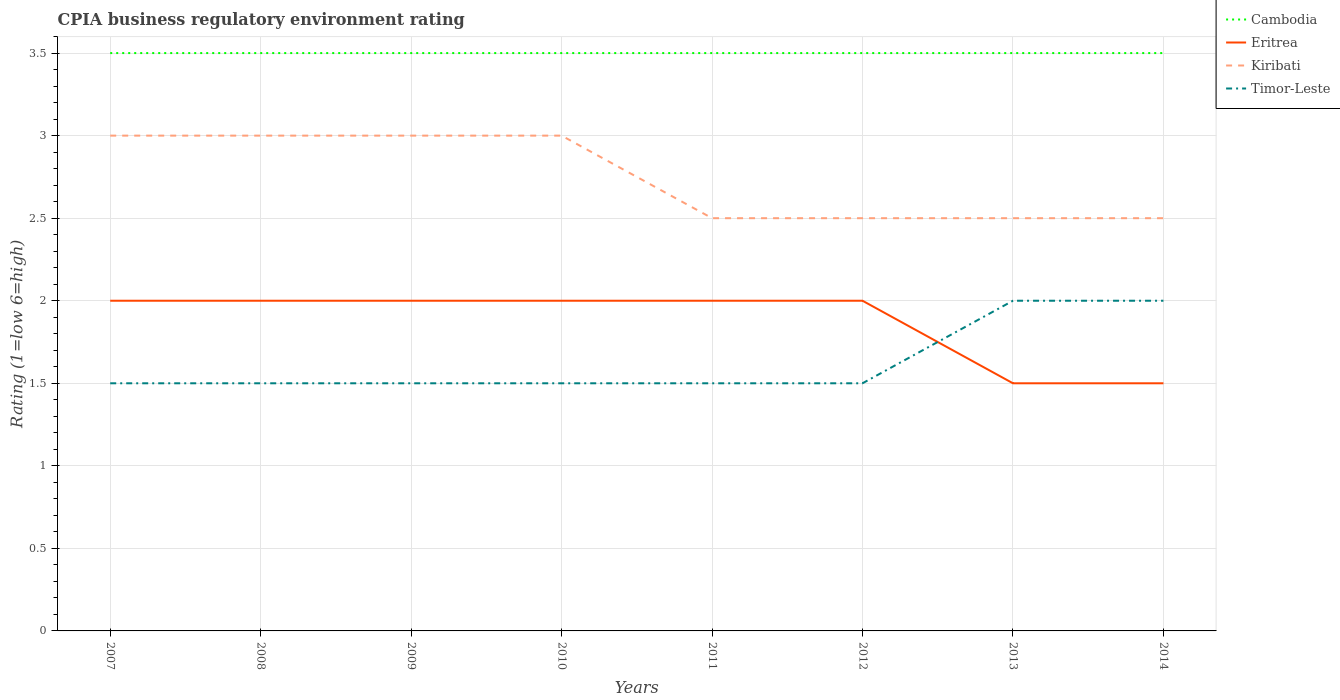In which year was the CPIA rating in Eritrea maximum?
Your answer should be compact. 2013. What is the difference between the highest and the lowest CPIA rating in Eritrea?
Give a very brief answer. 6. What is the difference between two consecutive major ticks on the Y-axis?
Your answer should be very brief. 0.5. Are the values on the major ticks of Y-axis written in scientific E-notation?
Offer a very short reply. No. Does the graph contain any zero values?
Provide a short and direct response. No. Does the graph contain grids?
Provide a succinct answer. Yes. How are the legend labels stacked?
Your answer should be very brief. Vertical. What is the title of the graph?
Ensure brevity in your answer.  CPIA business regulatory environment rating. Does "Greece" appear as one of the legend labels in the graph?
Provide a short and direct response. No. What is the label or title of the Y-axis?
Ensure brevity in your answer.  Rating (1=low 6=high). What is the Rating (1=low 6=high) in Eritrea in 2007?
Your answer should be very brief. 2. What is the Rating (1=low 6=high) of Kiribati in 2007?
Ensure brevity in your answer.  3. What is the Rating (1=low 6=high) in Cambodia in 2008?
Your response must be concise. 3.5. What is the Rating (1=low 6=high) in Eritrea in 2008?
Your answer should be very brief. 2. What is the Rating (1=low 6=high) in Kiribati in 2008?
Provide a short and direct response. 3. What is the Rating (1=low 6=high) in Timor-Leste in 2008?
Offer a very short reply. 1.5. What is the Rating (1=low 6=high) in Cambodia in 2009?
Give a very brief answer. 3.5. What is the Rating (1=low 6=high) of Eritrea in 2009?
Your answer should be compact. 2. What is the Rating (1=low 6=high) in Timor-Leste in 2009?
Your answer should be very brief. 1.5. What is the Rating (1=low 6=high) of Cambodia in 2010?
Keep it short and to the point. 3.5. What is the Rating (1=low 6=high) in Eritrea in 2010?
Provide a succinct answer. 2. What is the Rating (1=low 6=high) of Timor-Leste in 2010?
Your answer should be compact. 1.5. What is the Rating (1=low 6=high) of Eritrea in 2011?
Ensure brevity in your answer.  2. What is the Rating (1=low 6=high) of Timor-Leste in 2011?
Keep it short and to the point. 1.5. What is the Rating (1=low 6=high) in Eritrea in 2012?
Provide a succinct answer. 2. What is the Rating (1=low 6=high) of Cambodia in 2013?
Make the answer very short. 3.5. What is the Rating (1=low 6=high) of Timor-Leste in 2013?
Your response must be concise. 2. What is the Rating (1=low 6=high) of Cambodia in 2014?
Your response must be concise. 3.5. Across all years, what is the maximum Rating (1=low 6=high) in Kiribati?
Make the answer very short. 3. Across all years, what is the maximum Rating (1=low 6=high) in Timor-Leste?
Provide a short and direct response. 2. Across all years, what is the minimum Rating (1=low 6=high) of Eritrea?
Make the answer very short. 1.5. Across all years, what is the minimum Rating (1=low 6=high) of Timor-Leste?
Offer a very short reply. 1.5. What is the total Rating (1=low 6=high) of Kiribati in the graph?
Make the answer very short. 22. What is the total Rating (1=low 6=high) in Timor-Leste in the graph?
Your answer should be compact. 13. What is the difference between the Rating (1=low 6=high) in Kiribati in 2007 and that in 2009?
Offer a terse response. 0. What is the difference between the Rating (1=low 6=high) of Timor-Leste in 2007 and that in 2009?
Ensure brevity in your answer.  0. What is the difference between the Rating (1=low 6=high) in Cambodia in 2007 and that in 2010?
Provide a succinct answer. 0. What is the difference between the Rating (1=low 6=high) in Eritrea in 2007 and that in 2010?
Your response must be concise. 0. What is the difference between the Rating (1=low 6=high) in Kiribati in 2007 and that in 2010?
Offer a terse response. 0. What is the difference between the Rating (1=low 6=high) of Eritrea in 2007 and that in 2011?
Provide a short and direct response. 0. What is the difference between the Rating (1=low 6=high) of Kiribati in 2007 and that in 2011?
Offer a very short reply. 0.5. What is the difference between the Rating (1=low 6=high) of Eritrea in 2007 and that in 2012?
Ensure brevity in your answer.  0. What is the difference between the Rating (1=low 6=high) of Cambodia in 2007 and that in 2013?
Give a very brief answer. 0. What is the difference between the Rating (1=low 6=high) in Kiribati in 2007 and that in 2013?
Your answer should be compact. 0.5. What is the difference between the Rating (1=low 6=high) of Cambodia in 2007 and that in 2014?
Keep it short and to the point. 0. What is the difference between the Rating (1=low 6=high) of Eritrea in 2007 and that in 2014?
Provide a succinct answer. 0.5. What is the difference between the Rating (1=low 6=high) of Kiribati in 2007 and that in 2014?
Your answer should be compact. 0.5. What is the difference between the Rating (1=low 6=high) in Timor-Leste in 2007 and that in 2014?
Offer a terse response. -0.5. What is the difference between the Rating (1=low 6=high) in Cambodia in 2008 and that in 2010?
Ensure brevity in your answer.  0. What is the difference between the Rating (1=low 6=high) of Kiribati in 2008 and that in 2010?
Make the answer very short. 0. What is the difference between the Rating (1=low 6=high) in Cambodia in 2008 and that in 2011?
Provide a succinct answer. 0. What is the difference between the Rating (1=low 6=high) of Eritrea in 2008 and that in 2011?
Your answer should be very brief. 0. What is the difference between the Rating (1=low 6=high) in Kiribati in 2008 and that in 2012?
Provide a succinct answer. 0.5. What is the difference between the Rating (1=low 6=high) of Kiribati in 2008 and that in 2013?
Your response must be concise. 0.5. What is the difference between the Rating (1=low 6=high) of Timor-Leste in 2008 and that in 2013?
Your answer should be very brief. -0.5. What is the difference between the Rating (1=low 6=high) in Cambodia in 2008 and that in 2014?
Provide a short and direct response. 0. What is the difference between the Rating (1=low 6=high) in Eritrea in 2008 and that in 2014?
Your answer should be very brief. 0.5. What is the difference between the Rating (1=low 6=high) of Cambodia in 2009 and that in 2010?
Provide a succinct answer. 0. What is the difference between the Rating (1=low 6=high) of Eritrea in 2009 and that in 2010?
Your answer should be compact. 0. What is the difference between the Rating (1=low 6=high) in Kiribati in 2009 and that in 2010?
Give a very brief answer. 0. What is the difference between the Rating (1=low 6=high) of Timor-Leste in 2009 and that in 2010?
Make the answer very short. 0. What is the difference between the Rating (1=low 6=high) of Cambodia in 2009 and that in 2011?
Give a very brief answer. 0. What is the difference between the Rating (1=low 6=high) of Kiribati in 2009 and that in 2011?
Provide a short and direct response. 0.5. What is the difference between the Rating (1=low 6=high) of Timor-Leste in 2009 and that in 2011?
Your answer should be very brief. 0. What is the difference between the Rating (1=low 6=high) of Cambodia in 2009 and that in 2012?
Ensure brevity in your answer.  0. What is the difference between the Rating (1=low 6=high) of Kiribati in 2009 and that in 2012?
Give a very brief answer. 0.5. What is the difference between the Rating (1=low 6=high) in Timor-Leste in 2009 and that in 2012?
Provide a short and direct response. 0. What is the difference between the Rating (1=low 6=high) of Cambodia in 2009 and that in 2013?
Offer a terse response. 0. What is the difference between the Rating (1=low 6=high) of Cambodia in 2009 and that in 2014?
Your answer should be compact. 0. What is the difference between the Rating (1=low 6=high) in Kiribati in 2009 and that in 2014?
Give a very brief answer. 0.5. What is the difference between the Rating (1=low 6=high) of Timor-Leste in 2009 and that in 2014?
Ensure brevity in your answer.  -0.5. What is the difference between the Rating (1=low 6=high) in Cambodia in 2010 and that in 2011?
Offer a very short reply. 0. What is the difference between the Rating (1=low 6=high) in Eritrea in 2010 and that in 2011?
Give a very brief answer. 0. What is the difference between the Rating (1=low 6=high) of Kiribati in 2010 and that in 2011?
Your answer should be compact. 0.5. What is the difference between the Rating (1=low 6=high) of Cambodia in 2010 and that in 2012?
Offer a very short reply. 0. What is the difference between the Rating (1=low 6=high) of Eritrea in 2010 and that in 2012?
Your answer should be very brief. 0. What is the difference between the Rating (1=low 6=high) in Kiribati in 2010 and that in 2012?
Keep it short and to the point. 0.5. What is the difference between the Rating (1=low 6=high) in Timor-Leste in 2010 and that in 2012?
Your answer should be very brief. 0. What is the difference between the Rating (1=low 6=high) in Kiribati in 2010 and that in 2013?
Your answer should be compact. 0.5. What is the difference between the Rating (1=low 6=high) of Timor-Leste in 2010 and that in 2013?
Offer a very short reply. -0.5. What is the difference between the Rating (1=low 6=high) in Kiribati in 2010 and that in 2014?
Give a very brief answer. 0.5. What is the difference between the Rating (1=low 6=high) of Timor-Leste in 2010 and that in 2014?
Your response must be concise. -0.5. What is the difference between the Rating (1=low 6=high) in Eritrea in 2011 and that in 2012?
Offer a terse response. 0. What is the difference between the Rating (1=low 6=high) of Kiribati in 2011 and that in 2012?
Give a very brief answer. 0. What is the difference between the Rating (1=low 6=high) in Cambodia in 2011 and that in 2013?
Your answer should be compact. 0. What is the difference between the Rating (1=low 6=high) of Eritrea in 2011 and that in 2013?
Your answer should be very brief. 0.5. What is the difference between the Rating (1=low 6=high) of Kiribati in 2011 and that in 2013?
Your answer should be compact. 0. What is the difference between the Rating (1=low 6=high) in Cambodia in 2011 and that in 2014?
Offer a very short reply. 0. What is the difference between the Rating (1=low 6=high) in Timor-Leste in 2011 and that in 2014?
Offer a very short reply. -0.5. What is the difference between the Rating (1=low 6=high) of Eritrea in 2012 and that in 2013?
Your answer should be very brief. 0.5. What is the difference between the Rating (1=low 6=high) in Kiribati in 2012 and that in 2013?
Your answer should be compact. 0. What is the difference between the Rating (1=low 6=high) of Timor-Leste in 2012 and that in 2013?
Provide a succinct answer. -0.5. What is the difference between the Rating (1=low 6=high) of Eritrea in 2013 and that in 2014?
Your answer should be very brief. 0. What is the difference between the Rating (1=low 6=high) in Timor-Leste in 2013 and that in 2014?
Your answer should be compact. 0. What is the difference between the Rating (1=low 6=high) in Cambodia in 2007 and the Rating (1=low 6=high) in Eritrea in 2009?
Offer a terse response. 1.5. What is the difference between the Rating (1=low 6=high) of Eritrea in 2007 and the Rating (1=low 6=high) of Kiribati in 2009?
Your response must be concise. -1. What is the difference between the Rating (1=low 6=high) of Eritrea in 2007 and the Rating (1=low 6=high) of Timor-Leste in 2009?
Make the answer very short. 0.5. What is the difference between the Rating (1=low 6=high) of Eritrea in 2007 and the Rating (1=low 6=high) of Kiribati in 2010?
Offer a terse response. -1. What is the difference between the Rating (1=low 6=high) of Eritrea in 2007 and the Rating (1=low 6=high) of Timor-Leste in 2010?
Offer a terse response. 0.5. What is the difference between the Rating (1=low 6=high) of Cambodia in 2007 and the Rating (1=low 6=high) of Eritrea in 2011?
Your answer should be very brief. 1.5. What is the difference between the Rating (1=low 6=high) of Cambodia in 2007 and the Rating (1=low 6=high) of Kiribati in 2011?
Keep it short and to the point. 1. What is the difference between the Rating (1=low 6=high) of Eritrea in 2007 and the Rating (1=low 6=high) of Kiribati in 2011?
Provide a short and direct response. -0.5. What is the difference between the Rating (1=low 6=high) of Eritrea in 2007 and the Rating (1=low 6=high) of Timor-Leste in 2011?
Your answer should be very brief. 0.5. What is the difference between the Rating (1=low 6=high) of Kiribati in 2007 and the Rating (1=low 6=high) of Timor-Leste in 2011?
Provide a short and direct response. 1.5. What is the difference between the Rating (1=low 6=high) in Cambodia in 2007 and the Rating (1=low 6=high) in Eritrea in 2012?
Ensure brevity in your answer.  1.5. What is the difference between the Rating (1=low 6=high) of Cambodia in 2007 and the Rating (1=low 6=high) of Kiribati in 2012?
Your response must be concise. 1. What is the difference between the Rating (1=low 6=high) in Cambodia in 2007 and the Rating (1=low 6=high) in Timor-Leste in 2012?
Keep it short and to the point. 2. What is the difference between the Rating (1=low 6=high) in Eritrea in 2007 and the Rating (1=low 6=high) in Timor-Leste in 2012?
Offer a terse response. 0.5. What is the difference between the Rating (1=low 6=high) of Cambodia in 2007 and the Rating (1=low 6=high) of Timor-Leste in 2013?
Provide a succinct answer. 1.5. What is the difference between the Rating (1=low 6=high) in Eritrea in 2007 and the Rating (1=low 6=high) in Kiribati in 2013?
Ensure brevity in your answer.  -0.5. What is the difference between the Rating (1=low 6=high) in Eritrea in 2007 and the Rating (1=low 6=high) in Timor-Leste in 2013?
Offer a very short reply. 0. What is the difference between the Rating (1=low 6=high) in Cambodia in 2007 and the Rating (1=low 6=high) in Eritrea in 2014?
Your answer should be compact. 2. What is the difference between the Rating (1=low 6=high) of Eritrea in 2007 and the Rating (1=low 6=high) of Kiribati in 2014?
Offer a very short reply. -0.5. What is the difference between the Rating (1=low 6=high) of Eritrea in 2007 and the Rating (1=low 6=high) of Timor-Leste in 2014?
Ensure brevity in your answer.  0. What is the difference between the Rating (1=low 6=high) of Kiribati in 2007 and the Rating (1=low 6=high) of Timor-Leste in 2014?
Ensure brevity in your answer.  1. What is the difference between the Rating (1=low 6=high) in Cambodia in 2008 and the Rating (1=low 6=high) in Kiribati in 2009?
Ensure brevity in your answer.  0.5. What is the difference between the Rating (1=low 6=high) in Cambodia in 2008 and the Rating (1=low 6=high) in Timor-Leste in 2009?
Give a very brief answer. 2. What is the difference between the Rating (1=low 6=high) in Eritrea in 2008 and the Rating (1=low 6=high) in Kiribati in 2009?
Give a very brief answer. -1. What is the difference between the Rating (1=low 6=high) of Eritrea in 2008 and the Rating (1=low 6=high) of Timor-Leste in 2009?
Make the answer very short. 0.5. What is the difference between the Rating (1=low 6=high) of Cambodia in 2008 and the Rating (1=low 6=high) of Kiribati in 2010?
Ensure brevity in your answer.  0.5. What is the difference between the Rating (1=low 6=high) of Cambodia in 2008 and the Rating (1=low 6=high) of Timor-Leste in 2010?
Provide a succinct answer. 2. What is the difference between the Rating (1=low 6=high) of Eritrea in 2008 and the Rating (1=low 6=high) of Timor-Leste in 2011?
Ensure brevity in your answer.  0.5. What is the difference between the Rating (1=low 6=high) of Cambodia in 2008 and the Rating (1=low 6=high) of Kiribati in 2012?
Offer a terse response. 1. What is the difference between the Rating (1=low 6=high) of Eritrea in 2008 and the Rating (1=low 6=high) of Kiribati in 2012?
Offer a terse response. -0.5. What is the difference between the Rating (1=low 6=high) of Cambodia in 2008 and the Rating (1=low 6=high) of Eritrea in 2013?
Your response must be concise. 2. What is the difference between the Rating (1=low 6=high) of Cambodia in 2008 and the Rating (1=low 6=high) of Kiribati in 2013?
Your response must be concise. 1. What is the difference between the Rating (1=low 6=high) in Eritrea in 2008 and the Rating (1=low 6=high) in Timor-Leste in 2013?
Give a very brief answer. 0. What is the difference between the Rating (1=low 6=high) in Kiribati in 2008 and the Rating (1=low 6=high) in Timor-Leste in 2013?
Your answer should be compact. 1. What is the difference between the Rating (1=low 6=high) in Cambodia in 2008 and the Rating (1=low 6=high) in Eritrea in 2014?
Give a very brief answer. 2. What is the difference between the Rating (1=low 6=high) of Cambodia in 2008 and the Rating (1=low 6=high) of Timor-Leste in 2014?
Provide a short and direct response. 1.5. What is the difference between the Rating (1=low 6=high) of Cambodia in 2009 and the Rating (1=low 6=high) of Eritrea in 2010?
Keep it short and to the point. 1.5. What is the difference between the Rating (1=low 6=high) of Cambodia in 2009 and the Rating (1=low 6=high) of Kiribati in 2010?
Offer a terse response. 0.5. What is the difference between the Rating (1=low 6=high) of Cambodia in 2009 and the Rating (1=low 6=high) of Timor-Leste in 2010?
Offer a very short reply. 2. What is the difference between the Rating (1=low 6=high) of Eritrea in 2009 and the Rating (1=low 6=high) of Timor-Leste in 2010?
Your answer should be very brief. 0.5. What is the difference between the Rating (1=low 6=high) of Kiribati in 2009 and the Rating (1=low 6=high) of Timor-Leste in 2010?
Ensure brevity in your answer.  1.5. What is the difference between the Rating (1=low 6=high) of Cambodia in 2009 and the Rating (1=low 6=high) of Eritrea in 2011?
Ensure brevity in your answer.  1.5. What is the difference between the Rating (1=low 6=high) in Cambodia in 2009 and the Rating (1=low 6=high) in Eritrea in 2012?
Your answer should be very brief. 1.5. What is the difference between the Rating (1=low 6=high) of Kiribati in 2009 and the Rating (1=low 6=high) of Timor-Leste in 2012?
Keep it short and to the point. 1.5. What is the difference between the Rating (1=low 6=high) of Cambodia in 2009 and the Rating (1=low 6=high) of Kiribati in 2013?
Your response must be concise. 1. What is the difference between the Rating (1=low 6=high) of Eritrea in 2009 and the Rating (1=low 6=high) of Timor-Leste in 2013?
Make the answer very short. 0. What is the difference between the Rating (1=low 6=high) of Eritrea in 2009 and the Rating (1=low 6=high) of Timor-Leste in 2014?
Offer a terse response. 0. What is the difference between the Rating (1=low 6=high) of Kiribati in 2009 and the Rating (1=low 6=high) of Timor-Leste in 2014?
Make the answer very short. 1. What is the difference between the Rating (1=low 6=high) in Cambodia in 2010 and the Rating (1=low 6=high) in Eritrea in 2011?
Provide a short and direct response. 1.5. What is the difference between the Rating (1=low 6=high) in Cambodia in 2010 and the Rating (1=low 6=high) in Timor-Leste in 2011?
Provide a short and direct response. 2. What is the difference between the Rating (1=low 6=high) of Eritrea in 2010 and the Rating (1=low 6=high) of Timor-Leste in 2011?
Make the answer very short. 0.5. What is the difference between the Rating (1=low 6=high) in Cambodia in 2010 and the Rating (1=low 6=high) in Eritrea in 2012?
Keep it short and to the point. 1.5. What is the difference between the Rating (1=low 6=high) in Cambodia in 2010 and the Rating (1=low 6=high) in Kiribati in 2012?
Offer a terse response. 1. What is the difference between the Rating (1=low 6=high) of Cambodia in 2010 and the Rating (1=low 6=high) of Timor-Leste in 2012?
Provide a succinct answer. 2. What is the difference between the Rating (1=low 6=high) in Kiribati in 2010 and the Rating (1=low 6=high) in Timor-Leste in 2012?
Keep it short and to the point. 1.5. What is the difference between the Rating (1=low 6=high) in Cambodia in 2010 and the Rating (1=low 6=high) in Eritrea in 2013?
Provide a short and direct response. 2. What is the difference between the Rating (1=low 6=high) of Cambodia in 2010 and the Rating (1=low 6=high) of Kiribati in 2013?
Offer a very short reply. 1. What is the difference between the Rating (1=low 6=high) of Eritrea in 2010 and the Rating (1=low 6=high) of Timor-Leste in 2013?
Provide a short and direct response. 0. What is the difference between the Rating (1=low 6=high) of Cambodia in 2010 and the Rating (1=low 6=high) of Timor-Leste in 2014?
Your response must be concise. 1.5. What is the difference between the Rating (1=low 6=high) in Eritrea in 2010 and the Rating (1=low 6=high) in Timor-Leste in 2014?
Your response must be concise. 0. What is the difference between the Rating (1=low 6=high) of Kiribati in 2010 and the Rating (1=low 6=high) of Timor-Leste in 2014?
Your answer should be compact. 1. What is the difference between the Rating (1=low 6=high) of Cambodia in 2011 and the Rating (1=low 6=high) of Timor-Leste in 2012?
Your response must be concise. 2. What is the difference between the Rating (1=low 6=high) of Eritrea in 2011 and the Rating (1=low 6=high) of Kiribati in 2012?
Your answer should be very brief. -0.5. What is the difference between the Rating (1=low 6=high) in Cambodia in 2011 and the Rating (1=low 6=high) in Kiribati in 2013?
Your response must be concise. 1. What is the difference between the Rating (1=low 6=high) of Eritrea in 2011 and the Rating (1=low 6=high) of Kiribati in 2013?
Keep it short and to the point. -0.5. What is the difference between the Rating (1=low 6=high) in Kiribati in 2011 and the Rating (1=low 6=high) in Timor-Leste in 2013?
Your response must be concise. 0.5. What is the difference between the Rating (1=low 6=high) in Cambodia in 2011 and the Rating (1=low 6=high) in Timor-Leste in 2014?
Your answer should be very brief. 1.5. What is the difference between the Rating (1=low 6=high) in Eritrea in 2011 and the Rating (1=low 6=high) in Kiribati in 2014?
Offer a terse response. -0.5. What is the difference between the Rating (1=low 6=high) of Kiribati in 2011 and the Rating (1=low 6=high) of Timor-Leste in 2014?
Ensure brevity in your answer.  0.5. What is the difference between the Rating (1=low 6=high) of Eritrea in 2012 and the Rating (1=low 6=high) of Kiribati in 2013?
Ensure brevity in your answer.  -0.5. What is the difference between the Rating (1=low 6=high) in Eritrea in 2012 and the Rating (1=low 6=high) in Timor-Leste in 2013?
Make the answer very short. 0. What is the difference between the Rating (1=low 6=high) in Cambodia in 2012 and the Rating (1=low 6=high) in Kiribati in 2014?
Offer a very short reply. 1. What is the difference between the Rating (1=low 6=high) in Cambodia in 2012 and the Rating (1=low 6=high) in Timor-Leste in 2014?
Your answer should be compact. 1.5. What is the difference between the Rating (1=low 6=high) in Cambodia in 2013 and the Rating (1=low 6=high) in Eritrea in 2014?
Your answer should be compact. 2. What is the difference between the Rating (1=low 6=high) in Cambodia in 2013 and the Rating (1=low 6=high) in Kiribati in 2014?
Offer a terse response. 1. What is the difference between the Rating (1=low 6=high) of Cambodia in 2013 and the Rating (1=low 6=high) of Timor-Leste in 2014?
Offer a very short reply. 1.5. What is the difference between the Rating (1=low 6=high) in Eritrea in 2013 and the Rating (1=low 6=high) in Kiribati in 2014?
Keep it short and to the point. -1. What is the difference between the Rating (1=low 6=high) of Kiribati in 2013 and the Rating (1=low 6=high) of Timor-Leste in 2014?
Your answer should be compact. 0.5. What is the average Rating (1=low 6=high) of Eritrea per year?
Keep it short and to the point. 1.88. What is the average Rating (1=low 6=high) of Kiribati per year?
Make the answer very short. 2.75. What is the average Rating (1=low 6=high) of Timor-Leste per year?
Your answer should be very brief. 1.62. In the year 2007, what is the difference between the Rating (1=low 6=high) in Cambodia and Rating (1=low 6=high) in Kiribati?
Your answer should be compact. 0.5. In the year 2007, what is the difference between the Rating (1=low 6=high) of Cambodia and Rating (1=low 6=high) of Timor-Leste?
Keep it short and to the point. 2. In the year 2008, what is the difference between the Rating (1=low 6=high) of Eritrea and Rating (1=low 6=high) of Kiribati?
Provide a short and direct response. -1. In the year 2008, what is the difference between the Rating (1=low 6=high) in Kiribati and Rating (1=low 6=high) in Timor-Leste?
Provide a succinct answer. 1.5. In the year 2009, what is the difference between the Rating (1=low 6=high) of Cambodia and Rating (1=low 6=high) of Eritrea?
Provide a short and direct response. 1.5. In the year 2009, what is the difference between the Rating (1=low 6=high) in Cambodia and Rating (1=low 6=high) in Kiribati?
Offer a very short reply. 0.5. In the year 2009, what is the difference between the Rating (1=low 6=high) of Eritrea and Rating (1=low 6=high) of Kiribati?
Provide a short and direct response. -1. In the year 2009, what is the difference between the Rating (1=low 6=high) of Eritrea and Rating (1=low 6=high) of Timor-Leste?
Your response must be concise. 0.5. In the year 2009, what is the difference between the Rating (1=low 6=high) in Kiribati and Rating (1=low 6=high) in Timor-Leste?
Give a very brief answer. 1.5. In the year 2010, what is the difference between the Rating (1=low 6=high) of Cambodia and Rating (1=low 6=high) of Kiribati?
Offer a terse response. 0.5. In the year 2010, what is the difference between the Rating (1=low 6=high) of Cambodia and Rating (1=low 6=high) of Timor-Leste?
Provide a short and direct response. 2. In the year 2010, what is the difference between the Rating (1=low 6=high) of Eritrea and Rating (1=low 6=high) of Kiribati?
Offer a terse response. -1. In the year 2010, what is the difference between the Rating (1=low 6=high) in Eritrea and Rating (1=low 6=high) in Timor-Leste?
Give a very brief answer. 0.5. In the year 2010, what is the difference between the Rating (1=low 6=high) in Kiribati and Rating (1=low 6=high) in Timor-Leste?
Keep it short and to the point. 1.5. In the year 2011, what is the difference between the Rating (1=low 6=high) of Cambodia and Rating (1=low 6=high) of Eritrea?
Give a very brief answer. 1.5. In the year 2011, what is the difference between the Rating (1=low 6=high) of Cambodia and Rating (1=low 6=high) of Timor-Leste?
Ensure brevity in your answer.  2. In the year 2011, what is the difference between the Rating (1=low 6=high) of Kiribati and Rating (1=low 6=high) of Timor-Leste?
Your answer should be compact. 1. In the year 2012, what is the difference between the Rating (1=low 6=high) in Cambodia and Rating (1=low 6=high) in Eritrea?
Make the answer very short. 1.5. In the year 2012, what is the difference between the Rating (1=low 6=high) of Cambodia and Rating (1=low 6=high) of Kiribati?
Make the answer very short. 1. In the year 2012, what is the difference between the Rating (1=low 6=high) in Eritrea and Rating (1=low 6=high) in Kiribati?
Ensure brevity in your answer.  -0.5. In the year 2012, what is the difference between the Rating (1=low 6=high) in Eritrea and Rating (1=low 6=high) in Timor-Leste?
Provide a short and direct response. 0.5. In the year 2012, what is the difference between the Rating (1=low 6=high) of Kiribati and Rating (1=low 6=high) of Timor-Leste?
Make the answer very short. 1. In the year 2013, what is the difference between the Rating (1=low 6=high) of Cambodia and Rating (1=low 6=high) of Kiribati?
Your answer should be compact. 1. In the year 2013, what is the difference between the Rating (1=low 6=high) of Eritrea and Rating (1=low 6=high) of Kiribati?
Give a very brief answer. -1. In the year 2013, what is the difference between the Rating (1=low 6=high) of Eritrea and Rating (1=low 6=high) of Timor-Leste?
Keep it short and to the point. -0.5. In the year 2013, what is the difference between the Rating (1=low 6=high) in Kiribati and Rating (1=low 6=high) in Timor-Leste?
Your answer should be compact. 0.5. In the year 2014, what is the difference between the Rating (1=low 6=high) of Eritrea and Rating (1=low 6=high) of Kiribati?
Make the answer very short. -1. In the year 2014, what is the difference between the Rating (1=low 6=high) in Eritrea and Rating (1=low 6=high) in Timor-Leste?
Keep it short and to the point. -0.5. What is the ratio of the Rating (1=low 6=high) in Cambodia in 2007 to that in 2008?
Make the answer very short. 1. What is the ratio of the Rating (1=low 6=high) of Eritrea in 2007 to that in 2008?
Give a very brief answer. 1. What is the ratio of the Rating (1=low 6=high) of Kiribati in 2007 to that in 2008?
Ensure brevity in your answer.  1. What is the ratio of the Rating (1=low 6=high) of Cambodia in 2007 to that in 2009?
Provide a short and direct response. 1. What is the ratio of the Rating (1=low 6=high) in Eritrea in 2007 to that in 2009?
Offer a terse response. 1. What is the ratio of the Rating (1=low 6=high) in Timor-Leste in 2007 to that in 2009?
Provide a short and direct response. 1. What is the ratio of the Rating (1=low 6=high) of Cambodia in 2007 to that in 2012?
Your answer should be very brief. 1. What is the ratio of the Rating (1=low 6=high) in Kiribati in 2007 to that in 2012?
Give a very brief answer. 1.2. What is the ratio of the Rating (1=low 6=high) in Eritrea in 2007 to that in 2013?
Offer a terse response. 1.33. What is the ratio of the Rating (1=low 6=high) in Kiribati in 2007 to that in 2013?
Offer a terse response. 1.2. What is the ratio of the Rating (1=low 6=high) of Cambodia in 2007 to that in 2014?
Give a very brief answer. 1. What is the ratio of the Rating (1=low 6=high) of Kiribati in 2007 to that in 2014?
Your answer should be very brief. 1.2. What is the ratio of the Rating (1=low 6=high) in Timor-Leste in 2007 to that in 2014?
Offer a very short reply. 0.75. What is the ratio of the Rating (1=low 6=high) of Kiribati in 2008 to that in 2009?
Your answer should be very brief. 1. What is the ratio of the Rating (1=low 6=high) in Timor-Leste in 2008 to that in 2009?
Offer a very short reply. 1. What is the ratio of the Rating (1=low 6=high) in Cambodia in 2008 to that in 2010?
Make the answer very short. 1. What is the ratio of the Rating (1=low 6=high) in Eritrea in 2008 to that in 2010?
Offer a very short reply. 1. What is the ratio of the Rating (1=low 6=high) of Kiribati in 2008 to that in 2010?
Ensure brevity in your answer.  1. What is the ratio of the Rating (1=low 6=high) in Timor-Leste in 2008 to that in 2010?
Offer a terse response. 1. What is the ratio of the Rating (1=low 6=high) of Cambodia in 2008 to that in 2011?
Offer a very short reply. 1. What is the ratio of the Rating (1=low 6=high) of Eritrea in 2008 to that in 2011?
Ensure brevity in your answer.  1. What is the ratio of the Rating (1=low 6=high) in Kiribati in 2008 to that in 2011?
Keep it short and to the point. 1.2. What is the ratio of the Rating (1=low 6=high) of Timor-Leste in 2008 to that in 2011?
Offer a very short reply. 1. What is the ratio of the Rating (1=low 6=high) of Cambodia in 2008 to that in 2012?
Give a very brief answer. 1. What is the ratio of the Rating (1=low 6=high) of Eritrea in 2008 to that in 2012?
Make the answer very short. 1. What is the ratio of the Rating (1=low 6=high) of Timor-Leste in 2008 to that in 2012?
Your answer should be compact. 1. What is the ratio of the Rating (1=low 6=high) of Eritrea in 2008 to that in 2013?
Ensure brevity in your answer.  1.33. What is the ratio of the Rating (1=low 6=high) of Kiribati in 2008 to that in 2013?
Ensure brevity in your answer.  1.2. What is the ratio of the Rating (1=low 6=high) in Eritrea in 2008 to that in 2014?
Your response must be concise. 1.33. What is the ratio of the Rating (1=low 6=high) in Kiribati in 2008 to that in 2014?
Provide a succinct answer. 1.2. What is the ratio of the Rating (1=low 6=high) of Cambodia in 2009 to that in 2010?
Provide a short and direct response. 1. What is the ratio of the Rating (1=low 6=high) of Kiribati in 2009 to that in 2010?
Your answer should be compact. 1. What is the ratio of the Rating (1=low 6=high) of Timor-Leste in 2009 to that in 2010?
Your answer should be compact. 1. What is the ratio of the Rating (1=low 6=high) in Cambodia in 2009 to that in 2011?
Offer a terse response. 1. What is the ratio of the Rating (1=low 6=high) in Eritrea in 2009 to that in 2011?
Make the answer very short. 1. What is the ratio of the Rating (1=low 6=high) in Kiribati in 2009 to that in 2011?
Keep it short and to the point. 1.2. What is the ratio of the Rating (1=low 6=high) of Cambodia in 2009 to that in 2012?
Ensure brevity in your answer.  1. What is the ratio of the Rating (1=low 6=high) in Kiribati in 2009 to that in 2012?
Your answer should be very brief. 1.2. What is the ratio of the Rating (1=low 6=high) in Timor-Leste in 2009 to that in 2012?
Offer a terse response. 1. What is the ratio of the Rating (1=low 6=high) of Kiribati in 2009 to that in 2013?
Make the answer very short. 1.2. What is the ratio of the Rating (1=low 6=high) of Cambodia in 2009 to that in 2014?
Your answer should be compact. 1. What is the ratio of the Rating (1=low 6=high) of Timor-Leste in 2009 to that in 2014?
Give a very brief answer. 0.75. What is the ratio of the Rating (1=low 6=high) of Cambodia in 2010 to that in 2011?
Offer a very short reply. 1. What is the ratio of the Rating (1=low 6=high) of Timor-Leste in 2010 to that in 2011?
Offer a terse response. 1. What is the ratio of the Rating (1=low 6=high) of Cambodia in 2010 to that in 2012?
Your answer should be very brief. 1. What is the ratio of the Rating (1=low 6=high) in Eritrea in 2010 to that in 2012?
Offer a very short reply. 1. What is the ratio of the Rating (1=low 6=high) of Kiribati in 2010 to that in 2012?
Offer a terse response. 1.2. What is the ratio of the Rating (1=low 6=high) in Timor-Leste in 2010 to that in 2012?
Your response must be concise. 1. What is the ratio of the Rating (1=low 6=high) of Cambodia in 2010 to that in 2013?
Offer a very short reply. 1. What is the ratio of the Rating (1=low 6=high) in Kiribati in 2010 to that in 2013?
Provide a succinct answer. 1.2. What is the ratio of the Rating (1=low 6=high) of Timor-Leste in 2010 to that in 2013?
Your response must be concise. 0.75. What is the ratio of the Rating (1=low 6=high) of Timor-Leste in 2010 to that in 2014?
Your answer should be very brief. 0.75. What is the ratio of the Rating (1=low 6=high) of Eritrea in 2011 to that in 2012?
Make the answer very short. 1. What is the ratio of the Rating (1=low 6=high) of Kiribati in 2011 to that in 2012?
Your answer should be compact. 1. What is the ratio of the Rating (1=low 6=high) of Cambodia in 2011 to that in 2013?
Provide a succinct answer. 1. What is the ratio of the Rating (1=low 6=high) in Eritrea in 2011 to that in 2013?
Your answer should be very brief. 1.33. What is the ratio of the Rating (1=low 6=high) of Cambodia in 2011 to that in 2014?
Provide a succinct answer. 1. What is the ratio of the Rating (1=low 6=high) in Eritrea in 2011 to that in 2014?
Provide a succinct answer. 1.33. What is the ratio of the Rating (1=low 6=high) of Kiribati in 2011 to that in 2014?
Provide a short and direct response. 1. What is the ratio of the Rating (1=low 6=high) of Timor-Leste in 2011 to that in 2014?
Ensure brevity in your answer.  0.75. What is the ratio of the Rating (1=low 6=high) of Eritrea in 2012 to that in 2013?
Provide a short and direct response. 1.33. What is the ratio of the Rating (1=low 6=high) in Cambodia in 2012 to that in 2014?
Keep it short and to the point. 1. What is the ratio of the Rating (1=low 6=high) of Eritrea in 2012 to that in 2014?
Provide a short and direct response. 1.33. What is the ratio of the Rating (1=low 6=high) in Timor-Leste in 2012 to that in 2014?
Provide a succinct answer. 0.75. What is the ratio of the Rating (1=low 6=high) in Cambodia in 2013 to that in 2014?
Provide a short and direct response. 1. What is the ratio of the Rating (1=low 6=high) in Eritrea in 2013 to that in 2014?
Provide a succinct answer. 1. What is the difference between the highest and the second highest Rating (1=low 6=high) of Cambodia?
Offer a terse response. 0. What is the difference between the highest and the second highest Rating (1=low 6=high) in Eritrea?
Provide a short and direct response. 0. What is the difference between the highest and the second highest Rating (1=low 6=high) in Kiribati?
Provide a short and direct response. 0. What is the difference between the highest and the lowest Rating (1=low 6=high) of Cambodia?
Make the answer very short. 0. What is the difference between the highest and the lowest Rating (1=low 6=high) of Eritrea?
Your answer should be very brief. 0.5. What is the difference between the highest and the lowest Rating (1=low 6=high) of Timor-Leste?
Offer a very short reply. 0.5. 